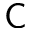Convert formula to latex. <formula><loc_0><loc_0><loc_500><loc_500>C</formula> 